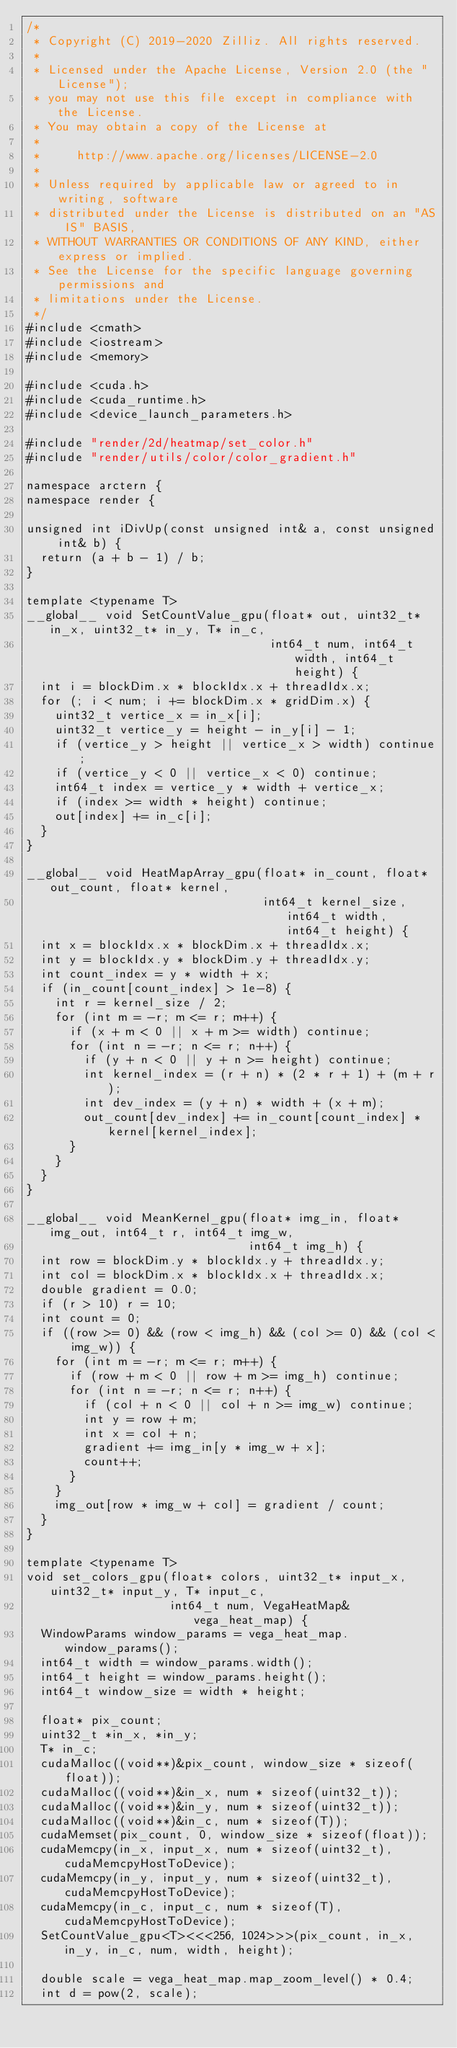Convert code to text. <code><loc_0><loc_0><loc_500><loc_500><_Cuda_>/*
 * Copyright (C) 2019-2020 Zilliz. All rights reserved.
 *
 * Licensed under the Apache License, Version 2.0 (the "License");
 * you may not use this file except in compliance with the License.
 * You may obtain a copy of the License at
 *
 *     http://www.apache.org/licenses/LICENSE-2.0
 *
 * Unless required by applicable law or agreed to in writing, software
 * distributed under the License is distributed on an "AS IS" BASIS,
 * WITHOUT WARRANTIES OR CONDITIONS OF ANY KIND, either express or implied.
 * See the License for the specific language governing permissions and
 * limitations under the License.
 */
#include <cmath>
#include <iostream>
#include <memory>

#include <cuda.h>
#include <cuda_runtime.h>
#include <device_launch_parameters.h>

#include "render/2d/heatmap/set_color.h"
#include "render/utils/color/color_gradient.h"

namespace arctern {
namespace render {

unsigned int iDivUp(const unsigned int& a, const unsigned int& b) {
  return (a + b - 1) / b;
}

template <typename T>
__global__ void SetCountValue_gpu(float* out, uint32_t* in_x, uint32_t* in_y, T* in_c,
                                  int64_t num, int64_t width, int64_t height) {
  int i = blockDim.x * blockIdx.x + threadIdx.x;
  for (; i < num; i += blockDim.x * gridDim.x) {
    uint32_t vertice_x = in_x[i];
    uint32_t vertice_y = height - in_y[i] - 1;
    if (vertice_y > height || vertice_x > width) continue;
    if (vertice_y < 0 || vertice_x < 0) continue;
    int64_t index = vertice_y * width + vertice_x;
    if (index >= width * height) continue;
    out[index] += in_c[i];
  }
}

__global__ void HeatMapArray_gpu(float* in_count, float* out_count, float* kernel,
                                 int64_t kernel_size, int64_t width, int64_t height) {
  int x = blockIdx.x * blockDim.x + threadIdx.x;
  int y = blockIdx.y * blockDim.y + threadIdx.y;
  int count_index = y * width + x;
  if (in_count[count_index] > 1e-8) {
    int r = kernel_size / 2;
    for (int m = -r; m <= r; m++) {
      if (x + m < 0 || x + m >= width) continue;
      for (int n = -r; n <= r; n++) {
        if (y + n < 0 || y + n >= height) continue;
        int kernel_index = (r + n) * (2 * r + 1) + (m + r);
        int dev_index = (y + n) * width + (x + m);
        out_count[dev_index] += in_count[count_index] * kernel[kernel_index];
      }
    }
  }
}

__global__ void MeanKernel_gpu(float* img_in, float* img_out, int64_t r, int64_t img_w,
                               int64_t img_h) {
  int row = blockDim.y * blockIdx.y + threadIdx.y;
  int col = blockDim.x * blockIdx.x + threadIdx.x;
  double gradient = 0.0;
  if (r > 10) r = 10;
  int count = 0;
  if ((row >= 0) && (row < img_h) && (col >= 0) && (col < img_w)) {
    for (int m = -r; m <= r; m++) {
      if (row + m < 0 || row + m >= img_h) continue;
      for (int n = -r; n <= r; n++) {
        if (col + n < 0 || col + n >= img_w) continue;
        int y = row + m;
        int x = col + n;
        gradient += img_in[y * img_w + x];
        count++;
      }
    }
    img_out[row * img_w + col] = gradient / count;
  }
}

template <typename T>
void set_colors_gpu(float* colors, uint32_t* input_x, uint32_t* input_y, T* input_c,
                    int64_t num, VegaHeatMap& vega_heat_map) {
  WindowParams window_params = vega_heat_map.window_params();
  int64_t width = window_params.width();
  int64_t height = window_params.height();
  int64_t window_size = width * height;

  float* pix_count;
  uint32_t *in_x, *in_y;
  T* in_c;
  cudaMalloc((void**)&pix_count, window_size * sizeof(float));
  cudaMalloc((void**)&in_x, num * sizeof(uint32_t));
  cudaMalloc((void**)&in_y, num * sizeof(uint32_t));
  cudaMalloc((void**)&in_c, num * sizeof(T));
  cudaMemset(pix_count, 0, window_size * sizeof(float));
  cudaMemcpy(in_x, input_x, num * sizeof(uint32_t), cudaMemcpyHostToDevice);
  cudaMemcpy(in_y, input_y, num * sizeof(uint32_t), cudaMemcpyHostToDevice);
  cudaMemcpy(in_c, input_c, num * sizeof(T), cudaMemcpyHostToDevice);
  SetCountValue_gpu<T><<<256, 1024>>>(pix_count, in_x, in_y, in_c, num, width, height);

  double scale = vega_heat_map.map_zoom_level() * 0.4;
  int d = pow(2, scale);</code> 